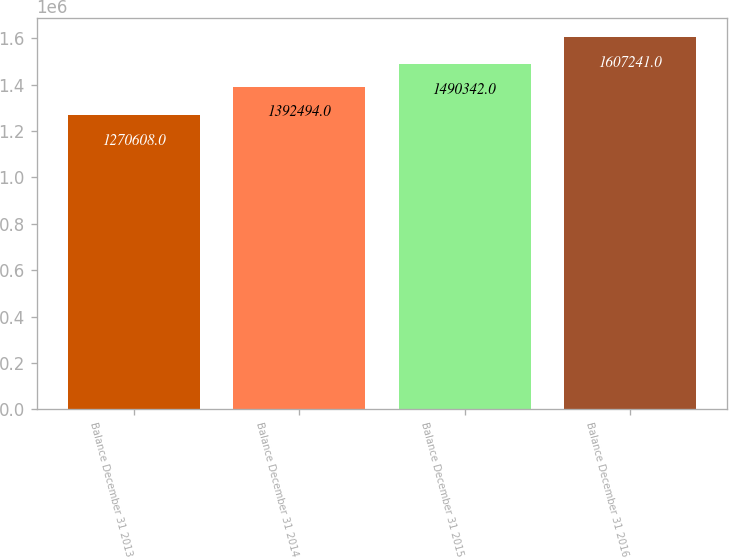<chart> <loc_0><loc_0><loc_500><loc_500><bar_chart><fcel>Balance December 31 2013<fcel>Balance December 31 2014<fcel>Balance December 31 2015<fcel>Balance December 31 2016<nl><fcel>1.27061e+06<fcel>1.39249e+06<fcel>1.49034e+06<fcel>1.60724e+06<nl></chart> 